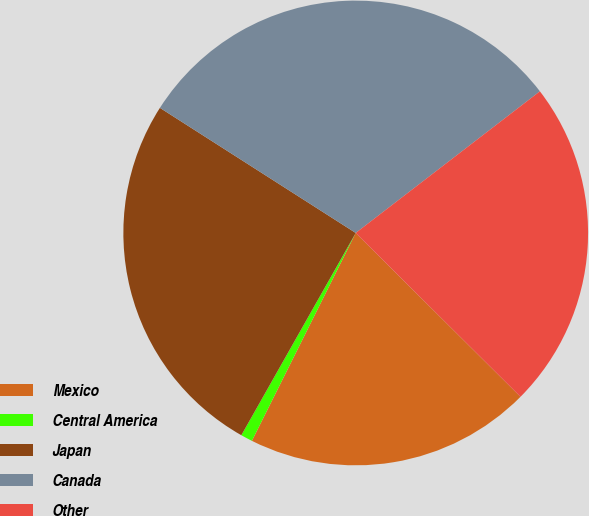Convert chart to OTSL. <chart><loc_0><loc_0><loc_500><loc_500><pie_chart><fcel>Mexico<fcel>Central America<fcel>Japan<fcel>Canada<fcel>Other<nl><fcel>19.92%<fcel>0.82%<fcel>25.86%<fcel>30.52%<fcel>22.89%<nl></chart> 